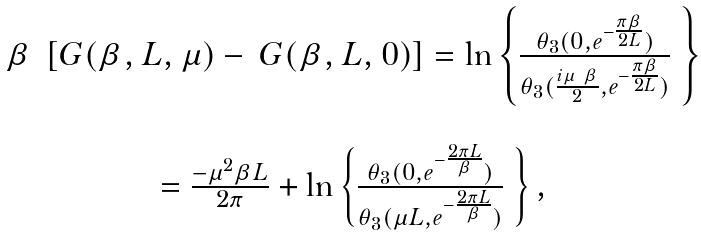Convert formula to latex. <formula><loc_0><loc_0><loc_500><loc_500>\begin{array} { c } \beta \ \left [ G ( \beta , L , \mu ) - \ G ( \beta , L , 0 ) \right ] = \ln \left \{ \frac { \theta _ { 3 } ( 0 , e ^ { - \frac { \pi \beta } { 2 L } } ) } { \theta _ { 3 } ( \frac { i \mu \ \beta } 2 , e ^ { - \frac { \pi \beta } { 2 L } } ) } \ \right \} \\ \\ = \frac { - \mu ^ { 2 } \beta L } { 2 \pi } + \ln \left \{ \frac { \theta _ { 3 } ( 0 , e ^ { - \frac { 2 \pi L } \beta } ) } { \theta _ { 3 } ( \mu L , e ^ { - \frac { 2 \pi L } \beta } ) } \ \right \} , \end{array}</formula> 